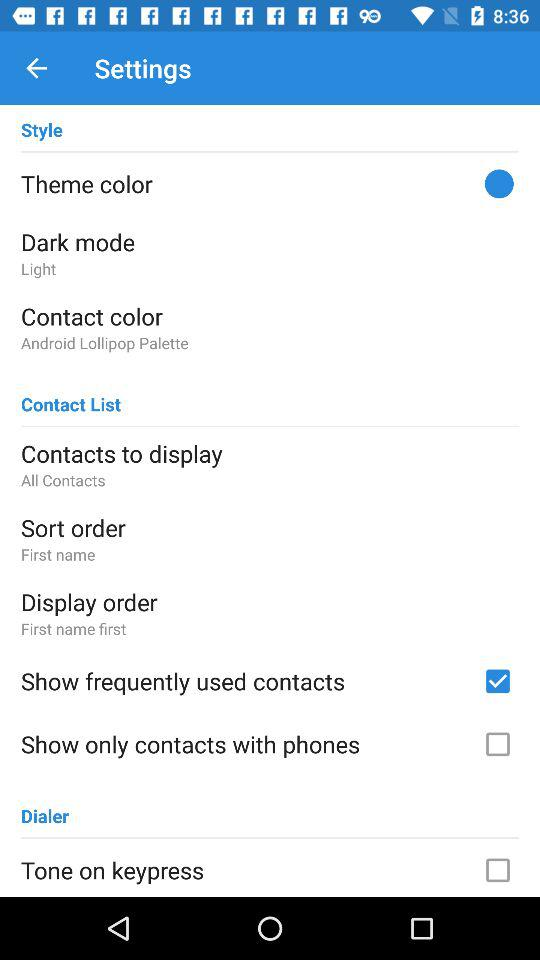What is the display order? The display order is "First name first". 